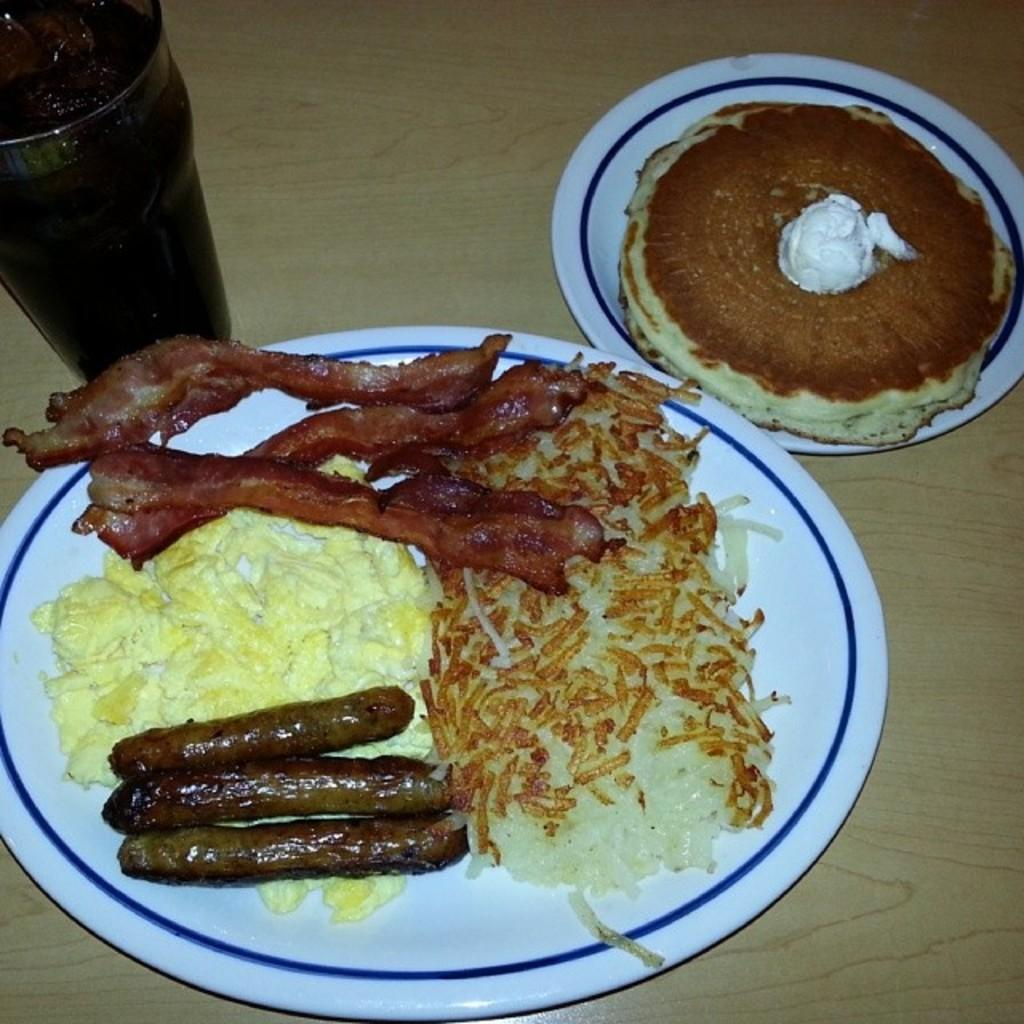What can be seen on the plates in the image? There are food items in plates in the image. What is in the glass that is visible in the image? There is a glass with liquid in the image. What is the object on which the food items and glass are placed? The food items and glass are placed on an object, but the specific type of object is not mentioned in the facts. Is there a bear playing in the dirt near the food items and glass in the image? No, there is no bear or dirt present in the image. The image only contains food items in plates, a glass with liquid, and an unspecified object on which they are placed. 